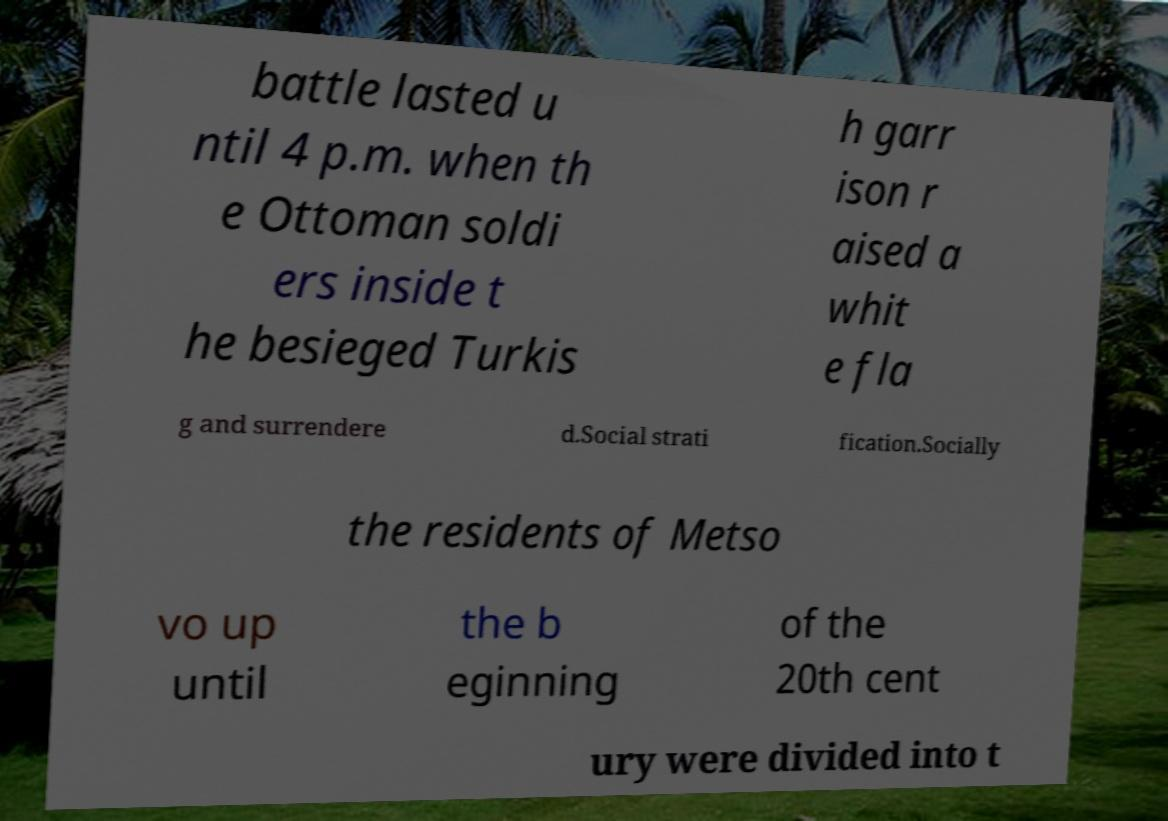Please read and relay the text visible in this image. What does it say? battle lasted u ntil 4 p.m. when th e Ottoman soldi ers inside t he besieged Turkis h garr ison r aised a whit e fla g and surrendere d.Social strati fication.Socially the residents of Metso vo up until the b eginning of the 20th cent ury were divided into t 